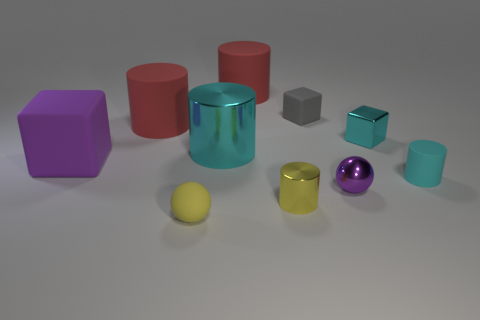Subtract 1 blocks. How many blocks are left? 2 Subtract all cyan cubes. How many red cylinders are left? 2 Subtract all large rubber cubes. How many cubes are left? 2 Subtract all red cylinders. How many cylinders are left? 3 Subtract all yellow cylinders. Subtract all red spheres. How many cylinders are left? 4 Subtract all balls. How many objects are left? 8 Add 8 small cyan cylinders. How many small cyan cylinders exist? 9 Subtract 1 yellow balls. How many objects are left? 9 Subtract all gray shiny things. Subtract all small cyan rubber cylinders. How many objects are left? 9 Add 9 tiny purple shiny objects. How many tiny purple shiny objects are left? 10 